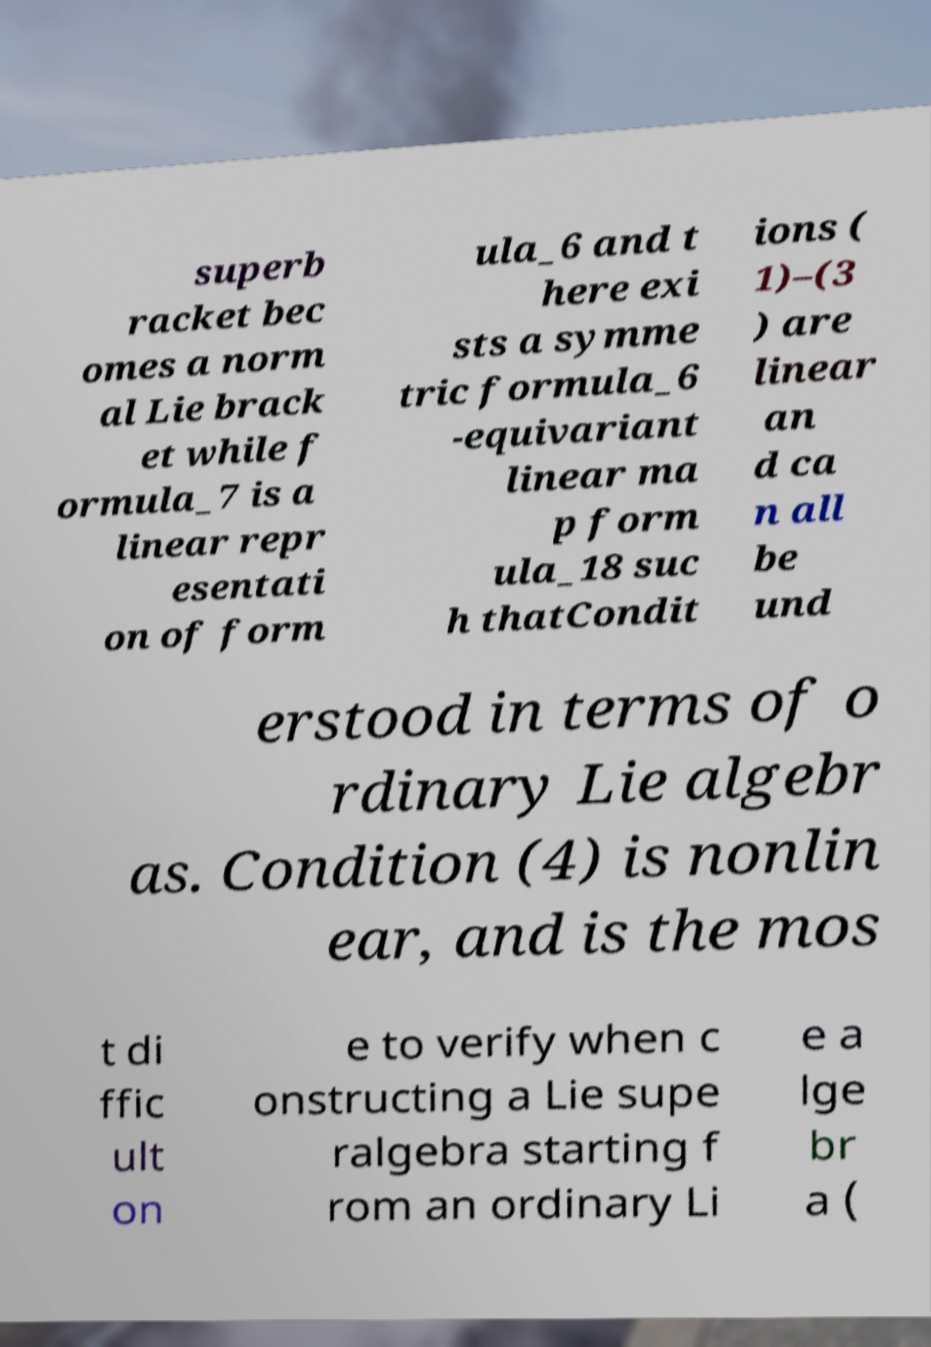I need the written content from this picture converted into text. Can you do that? superb racket bec omes a norm al Lie brack et while f ormula_7 is a linear repr esentati on of form ula_6 and t here exi sts a symme tric formula_6 -equivariant linear ma p form ula_18 suc h thatCondit ions ( 1)–(3 ) are linear an d ca n all be und erstood in terms of o rdinary Lie algebr as. Condition (4) is nonlin ear, and is the mos t di ffic ult on e to verify when c onstructing a Lie supe ralgebra starting f rom an ordinary Li e a lge br a ( 